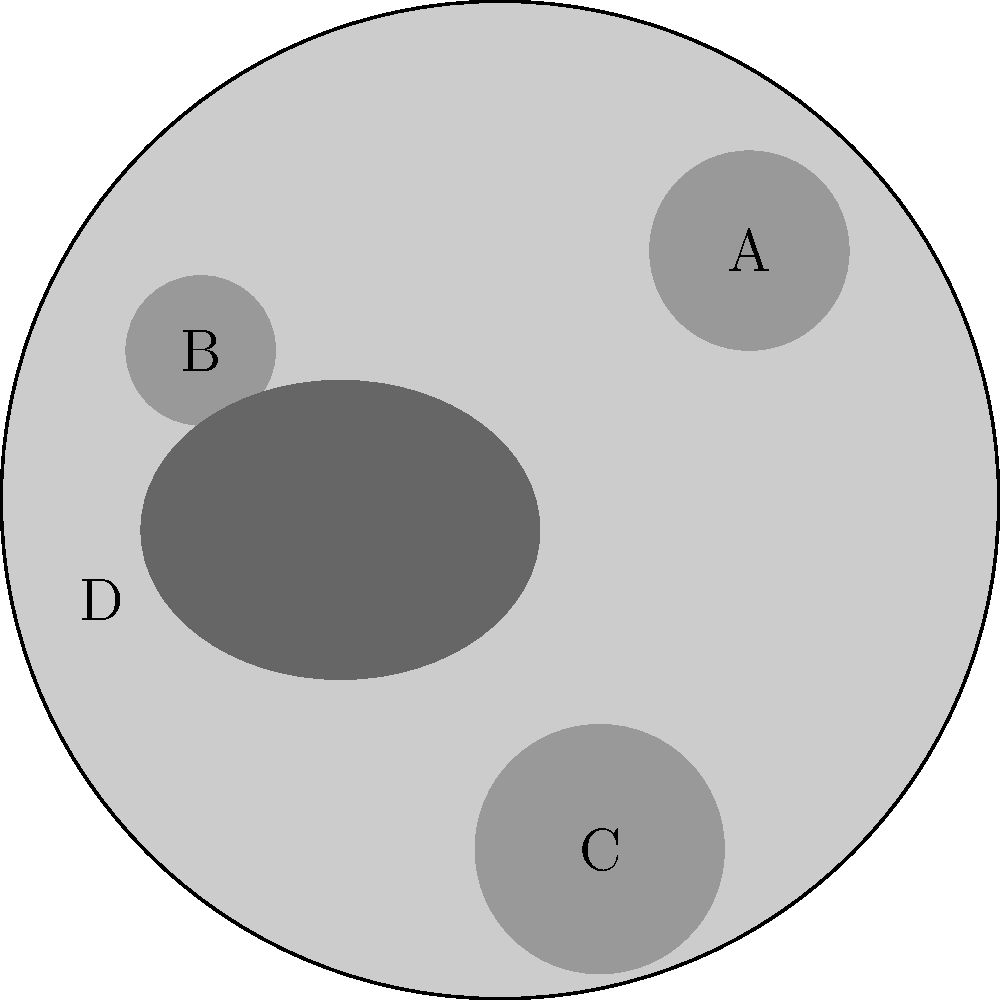As a market researcher analyzing lunar surface data, you encounter the following map of the Moon's surface. Which feature, labeled A, B, C, or D, represents a mare, a dark, basaltic plain formed by ancient volcanic eruptions? To identify the mare on this lunar surface map, let's analyze each labeled feature:

1. Feature A: This is a large, circular depression with a defined rim. Its appearance is consistent with an impact crater.

2. Feature B: Another circular depression, smaller than A but with similar characteristics. This also appears to be an impact crater.

3. Feature C: The largest circular depression on the map, again with a defined rim. This is another impact crater.

4. Feature D: This feature is distinctly different from the others. It has an irregular shape, is larger than the craters, and appears darker (represented by a darker shade of gray on the map).

Mares on the Moon have the following characteristics:
- They are large, dark areas on the lunar surface.
- They have irregular shapes, unlike the circular form of impact craters.
- They are formed by ancient volcanic eruptions, filling large impact basins with basaltic lava.

Based on these characteristics, feature D most closely matches the description of a mare. It is larger, darker, and more irregularly shaped than the other features, which are all consistent with impact craters.

For database structuring, this information could be stored in a table with fields for feature ID, feature type, size, shape, and albedo (brightness), allowing for efficient querying and analysis of lunar surface features.
Answer: D 